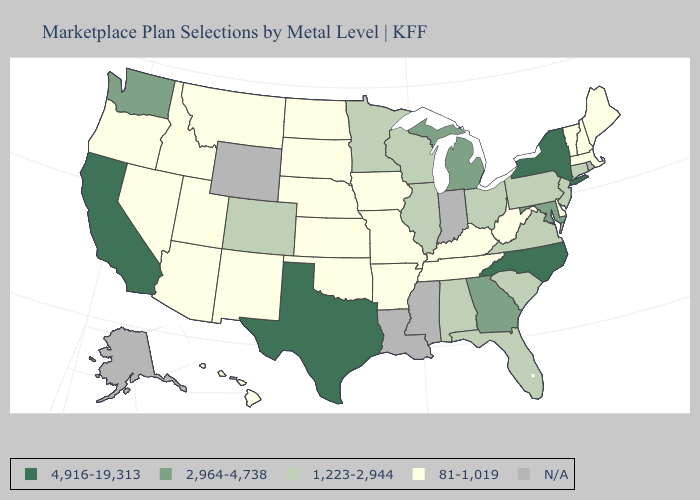What is the lowest value in the USA?
Concise answer only. 81-1,019. Name the states that have a value in the range 2,964-4,738?
Write a very short answer. Georgia, Maryland, Michigan, Washington. Name the states that have a value in the range 81-1,019?
Write a very short answer. Arizona, Arkansas, Delaware, Hawaii, Idaho, Iowa, Kansas, Kentucky, Maine, Massachusetts, Missouri, Montana, Nebraska, Nevada, New Hampshire, New Mexico, North Dakota, Oklahoma, Oregon, South Dakota, Tennessee, Utah, Vermont, West Virginia. Which states have the highest value in the USA?
Give a very brief answer. California, New York, North Carolina, Texas. Does Illinois have the lowest value in the USA?
Concise answer only. No. Name the states that have a value in the range N/A?
Short answer required. Alaska, Indiana, Louisiana, Mississippi, Rhode Island, Wyoming. What is the highest value in the West ?
Write a very short answer. 4,916-19,313. What is the value of Kansas?
Quick response, please. 81-1,019. What is the highest value in the USA?
Be succinct. 4,916-19,313. What is the highest value in states that border Washington?
Quick response, please. 81-1,019. Name the states that have a value in the range 4,916-19,313?
Give a very brief answer. California, New York, North Carolina, Texas. Which states have the lowest value in the South?
Quick response, please. Arkansas, Delaware, Kentucky, Oklahoma, Tennessee, West Virginia. Does Maryland have the lowest value in the USA?
Short answer required. No. 